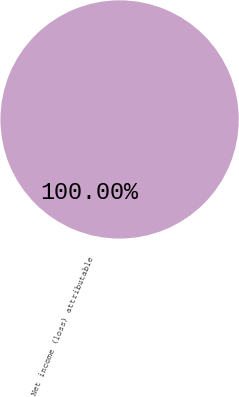Convert chart to OTSL. <chart><loc_0><loc_0><loc_500><loc_500><pie_chart><fcel>Net income (loss) attributable<nl><fcel>100.0%<nl></chart> 